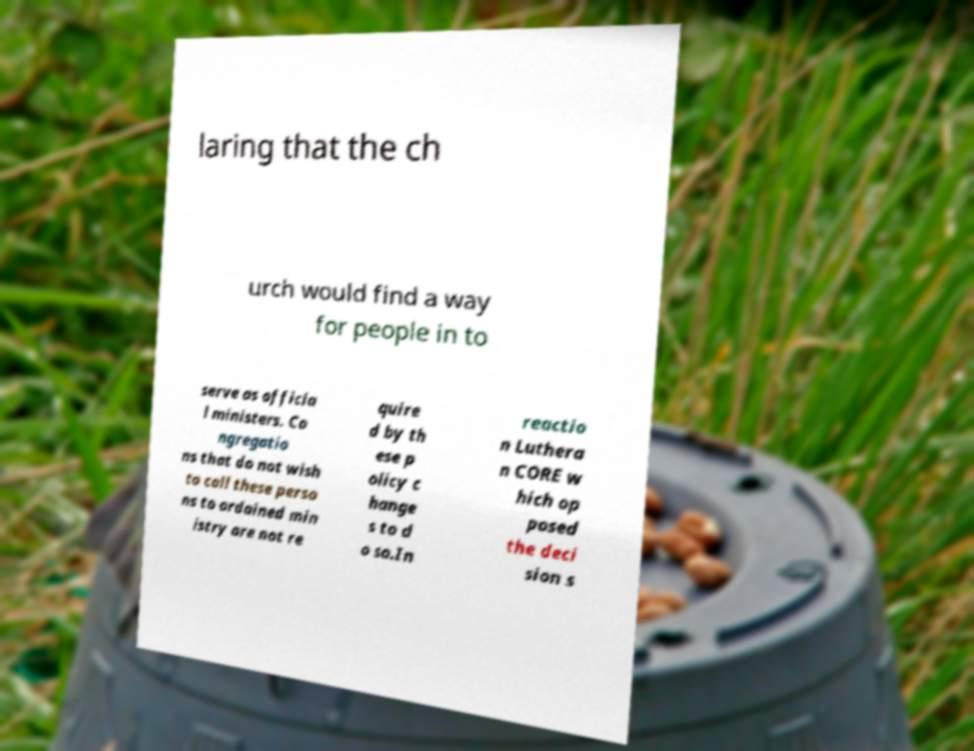Can you read and provide the text displayed in the image?This photo seems to have some interesting text. Can you extract and type it out for me? laring that the ch urch would find a way for people in to serve as officia l ministers. Co ngregatio ns that do not wish to call these perso ns to ordained min istry are not re quire d by th ese p olicy c hange s to d o so.In reactio n Luthera n CORE w hich op posed the deci sion s 